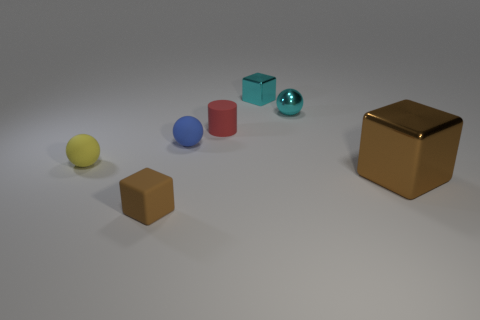Add 1 big brown rubber objects. How many objects exist? 8 Subtract all big brown metal cubes. How many cubes are left? 2 Subtract 2 spheres. How many spheres are left? 1 Subtract all cyan cubes. How many cubes are left? 2 Subtract 0 gray spheres. How many objects are left? 7 Subtract all cylinders. How many objects are left? 6 Subtract all red cubes. Subtract all gray cylinders. How many cubes are left? 3 Subtract all brown cylinders. How many cyan blocks are left? 1 Subtract all small blue balls. Subtract all tiny rubber cylinders. How many objects are left? 5 Add 7 small blue rubber objects. How many small blue rubber objects are left? 8 